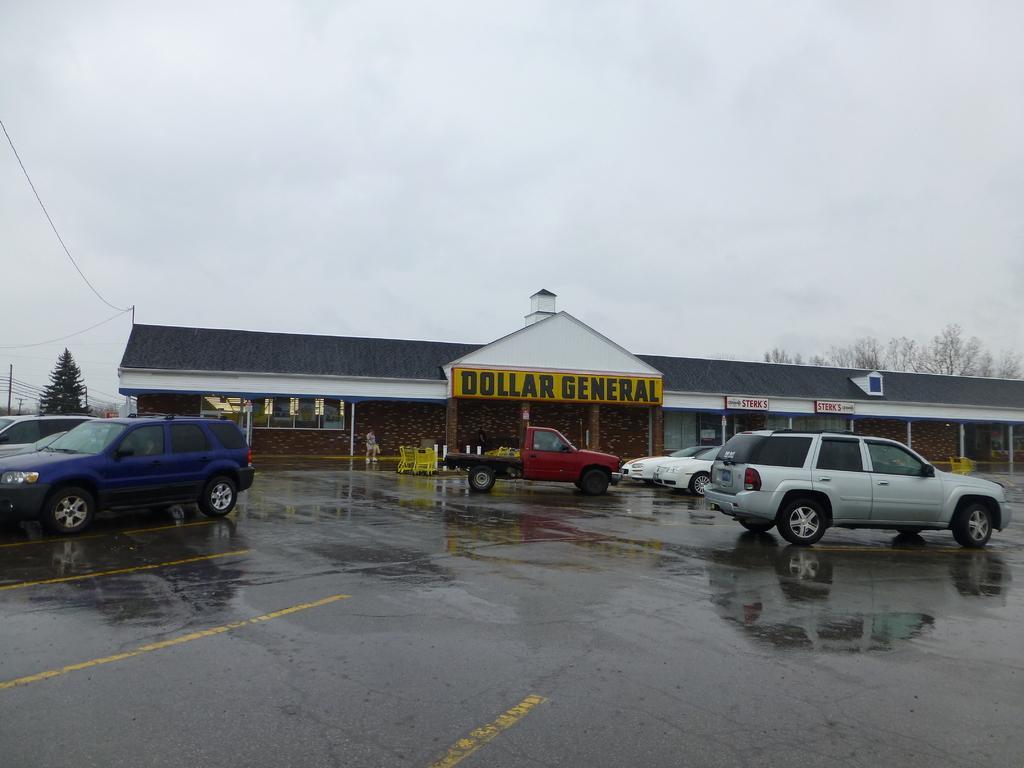Please provide a concise description of this image. In this image we can see a road and groups of cars parked on the road. Behind the cars there was a building with some text written on it. On the left side of the image we can see a pole and a tree. 